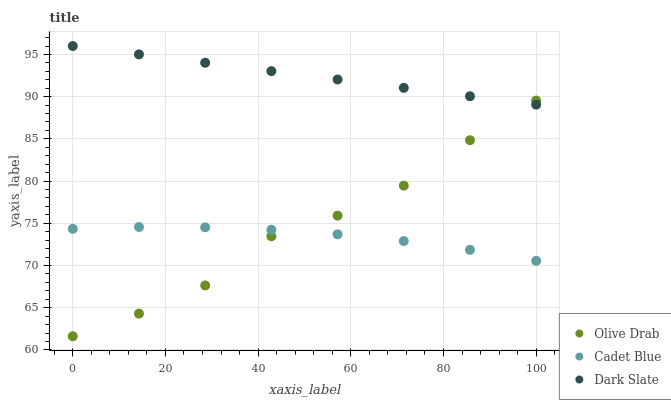Does Cadet Blue have the minimum area under the curve?
Answer yes or no. Yes. Does Dark Slate have the maximum area under the curve?
Answer yes or no. Yes. Does Olive Drab have the minimum area under the curve?
Answer yes or no. No. Does Olive Drab have the maximum area under the curve?
Answer yes or no. No. Is Dark Slate the smoothest?
Answer yes or no. Yes. Is Olive Drab the roughest?
Answer yes or no. Yes. Is Cadet Blue the smoothest?
Answer yes or no. No. Is Cadet Blue the roughest?
Answer yes or no. No. Does Olive Drab have the lowest value?
Answer yes or no. Yes. Does Cadet Blue have the lowest value?
Answer yes or no. No. Does Dark Slate have the highest value?
Answer yes or no. Yes. Does Olive Drab have the highest value?
Answer yes or no. No. Is Cadet Blue less than Dark Slate?
Answer yes or no. Yes. Is Dark Slate greater than Cadet Blue?
Answer yes or no. Yes. Does Dark Slate intersect Olive Drab?
Answer yes or no. Yes. Is Dark Slate less than Olive Drab?
Answer yes or no. No. Is Dark Slate greater than Olive Drab?
Answer yes or no. No. Does Cadet Blue intersect Dark Slate?
Answer yes or no. No. 